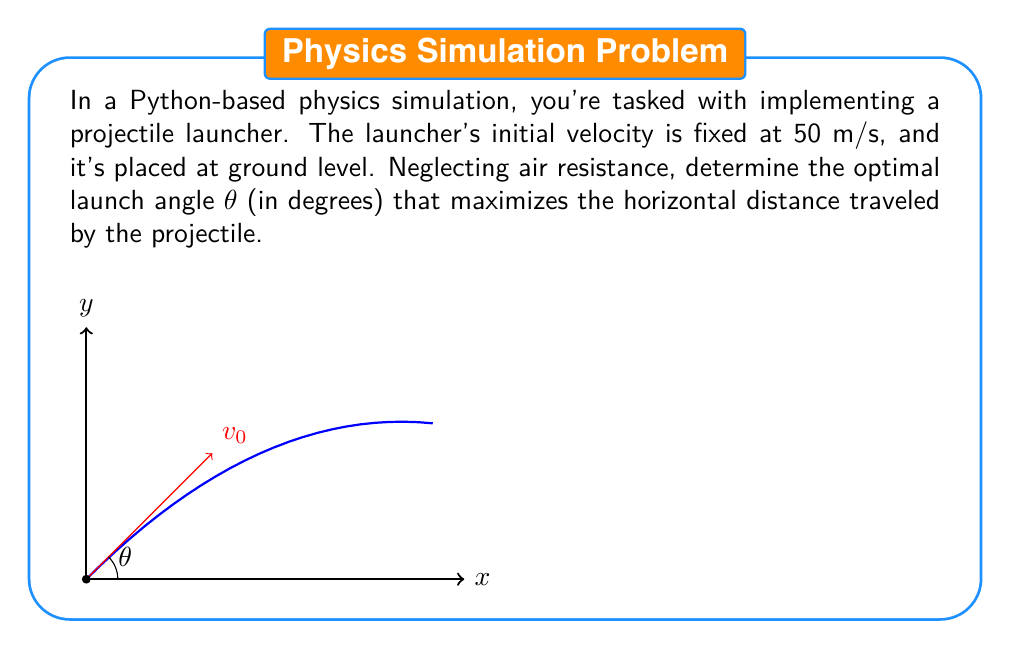Solve this math problem. To solve this problem, we'll use the equations of projectile motion and calculus to maximize the horizontal distance.

1) The horizontal distance x traveled by a projectile launched at angle θ with initial velocity v₀ is given by:

   $$x = \frac{v_0^2 \sin(2\theta)}{g}$$

   where g is the acceleration due to gravity (9.8 m/s²).

2) To find the maximum distance, we need to find the value of θ that maximizes this function. We can do this by taking the derivative with respect to θ and setting it to zero:

   $$\frac{dx}{d\theta} = \frac{v_0^2}{g} \cdot 2\cos(2\theta) = 0$$

3) Solving this equation:
   
   $$2\cos(2\theta) = 0$$
   $$\cos(2\theta) = 0$$
   $$2\theta = \frac{\pi}{2}$$
   $$\theta = \frac{\pi}{4} = 45°$$

4) The second derivative is negative at this point, confirming it's a maximum.

5) Therefore, the optimal launch angle for maximum distance is 45°, regardless of the initial velocity (assuming no air resistance).

In Python, you could implement this as:

```python
import math

def optimal_launch_angle():
    return math.degrees(math.pi / 4)

print(f"Optimal launch angle: {optimal_launch_angle()} degrees")
```

This result aligns with the well-known fact in physics that 45° is the optimal launch angle for maximum range in a vacuum.
Answer: 45° 